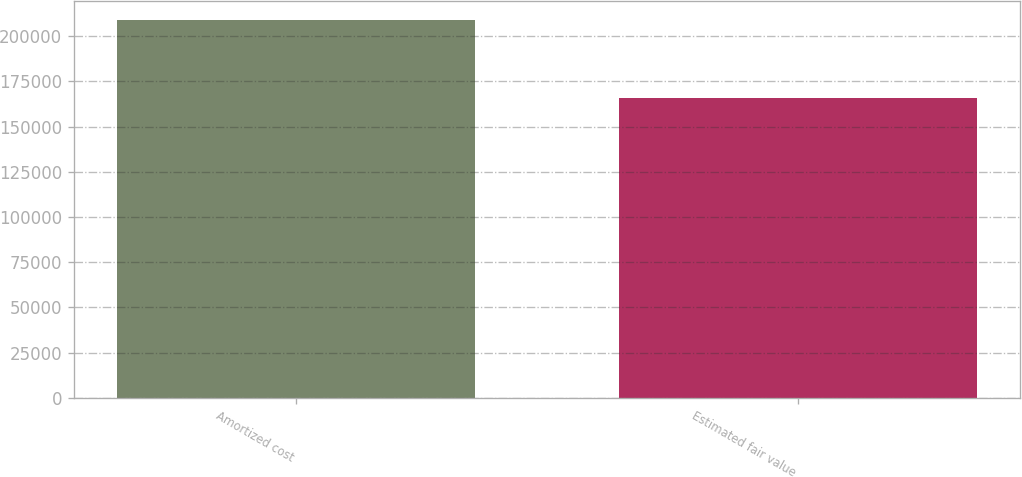<chart> <loc_0><loc_0><loc_500><loc_500><bar_chart><fcel>Amortized cost<fcel>Estimated fair value<nl><fcel>209107<fcel>165860<nl></chart> 